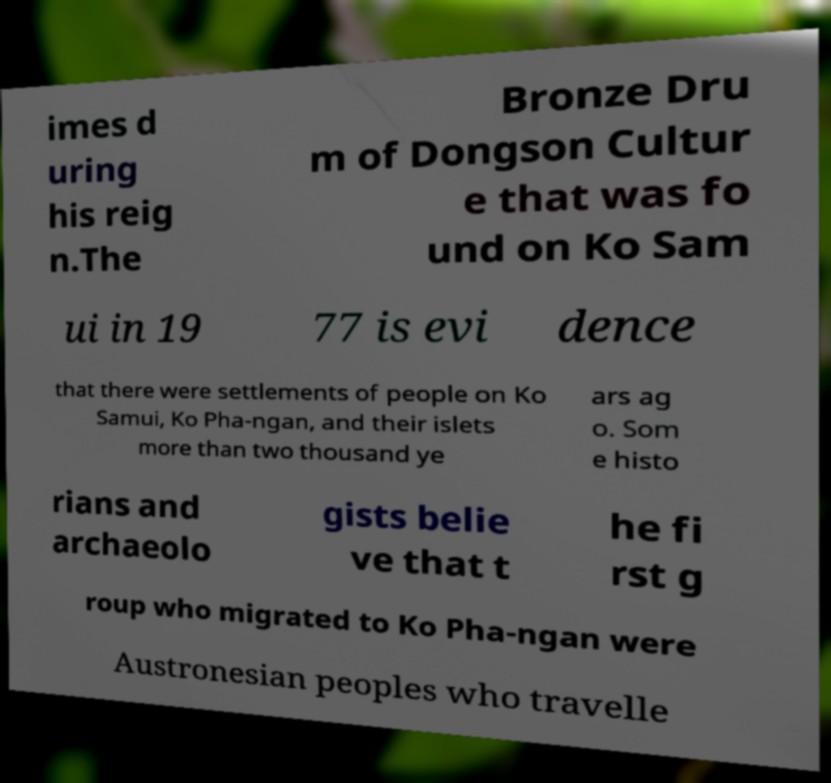For documentation purposes, I need the text within this image transcribed. Could you provide that? imes d uring his reig n.The Bronze Dru m of Dongson Cultur e that was fo und on Ko Sam ui in 19 77 is evi dence that there were settlements of people on Ko Samui, Ko Pha-ngan, and their islets more than two thousand ye ars ag o. Som e histo rians and archaeolo gists belie ve that t he fi rst g roup who migrated to Ko Pha-ngan were Austronesian peoples who travelle 